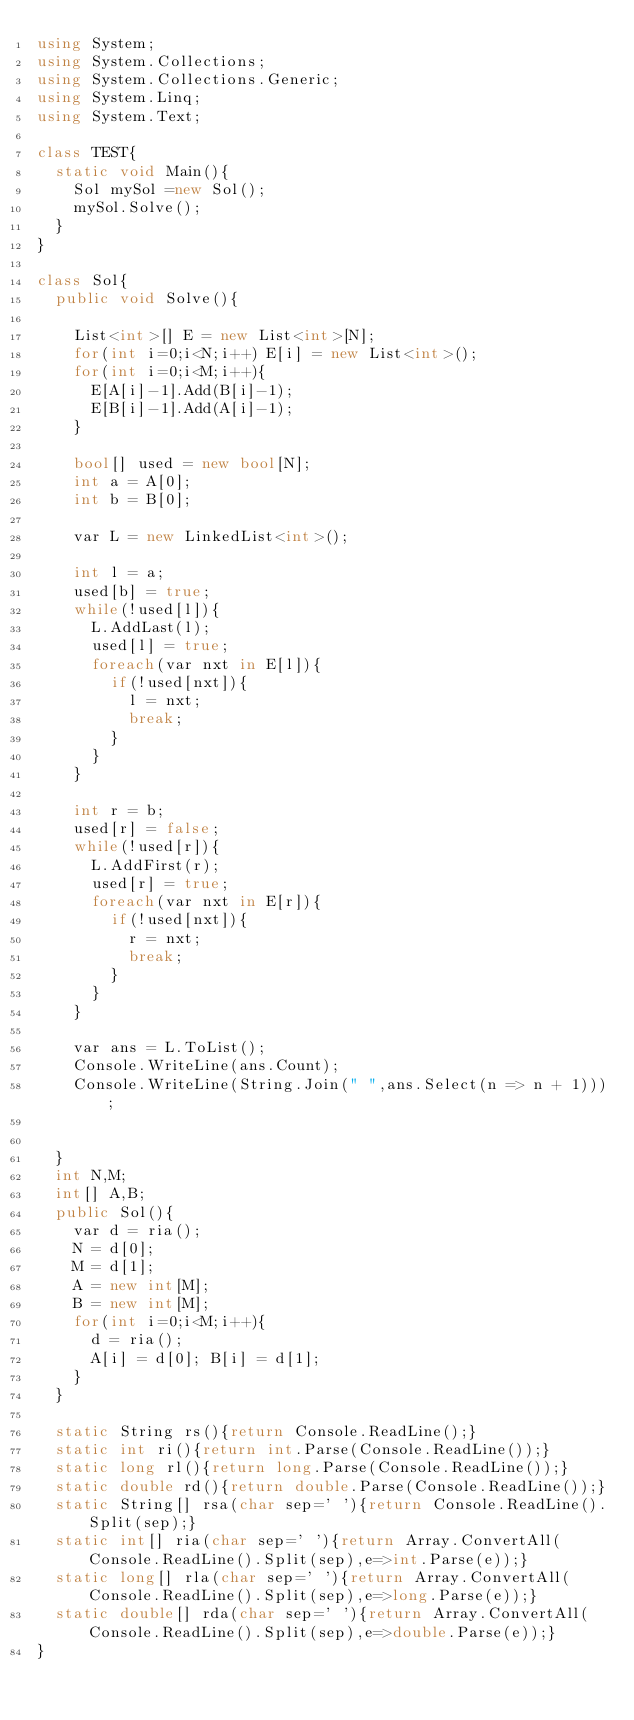Convert code to text. <code><loc_0><loc_0><loc_500><loc_500><_C#_>using System;
using System.Collections;
using System.Collections.Generic;
using System.Linq;
using System.Text;

class TEST{
	static void Main(){
		Sol mySol =new Sol();
		mySol.Solve();
	}
}

class Sol{
	public void Solve(){
		
		List<int>[] E = new List<int>[N];
		for(int i=0;i<N;i++) E[i] = new List<int>();
		for(int i=0;i<M;i++){
			E[A[i]-1].Add(B[i]-1);
			E[B[i]-1].Add(A[i]-1);
		}
		
		bool[] used = new bool[N];
		int a = A[0];
		int b = B[0];
		
		var L = new LinkedList<int>();
		
		int l = a;
		used[b] = true;
		while(!used[l]){
			L.AddLast(l);
			used[l] = true;
			foreach(var nxt in E[l]){
				if(!used[nxt]){
					l = nxt;
					break;
				}
			}
		}
		
		int r = b;
		used[r] = false;
		while(!used[r]){
			L.AddFirst(r);
			used[r] = true;
			foreach(var nxt in E[r]){
				if(!used[nxt]){
					r = nxt;
					break;
				}
			}
		}
		
		var ans = L.ToList();
		Console.WriteLine(ans.Count);
		Console.WriteLine(String.Join(" ",ans.Select(n => n + 1)));
		
		
	}
	int N,M;
	int[] A,B;
	public Sol(){
		var d = ria();
		N = d[0];
		M = d[1];
		A = new int[M];
		B = new int[M];
		for(int i=0;i<M;i++){
			d = ria();
			A[i] = d[0]; B[i] = d[1];
		}
	}

	static String rs(){return Console.ReadLine();}
	static int ri(){return int.Parse(Console.ReadLine());}
	static long rl(){return long.Parse(Console.ReadLine());}
	static double rd(){return double.Parse(Console.ReadLine());}
	static String[] rsa(char sep=' '){return Console.ReadLine().Split(sep);}
	static int[] ria(char sep=' '){return Array.ConvertAll(Console.ReadLine().Split(sep),e=>int.Parse(e));}
	static long[] rla(char sep=' '){return Array.ConvertAll(Console.ReadLine().Split(sep),e=>long.Parse(e));}
	static double[] rda(char sep=' '){return Array.ConvertAll(Console.ReadLine().Split(sep),e=>double.Parse(e));}
}
</code> 